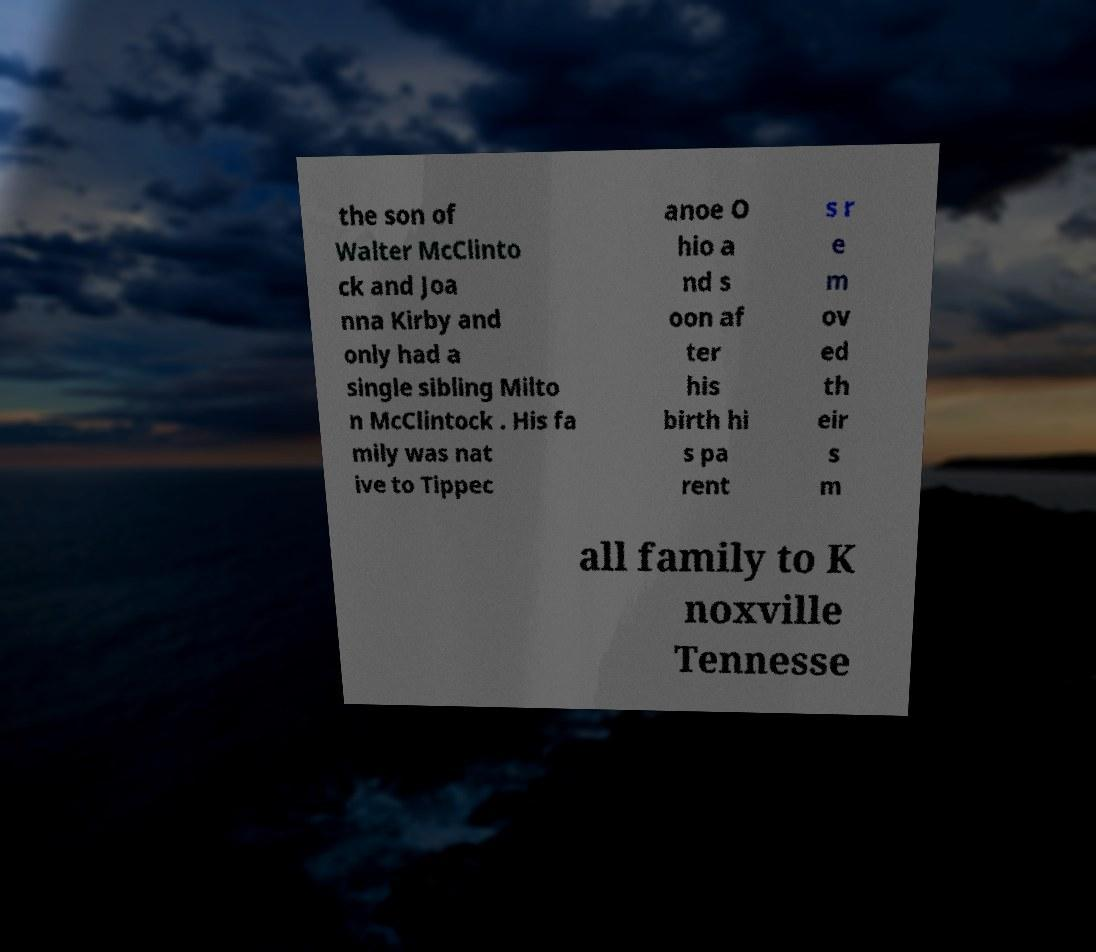Please read and relay the text visible in this image. What does it say? the son of Walter McClinto ck and Joa nna Kirby and only had a single sibling Milto n McClintock . His fa mily was nat ive to Tippec anoe O hio a nd s oon af ter his birth hi s pa rent s r e m ov ed th eir s m all family to K noxville Tennesse 